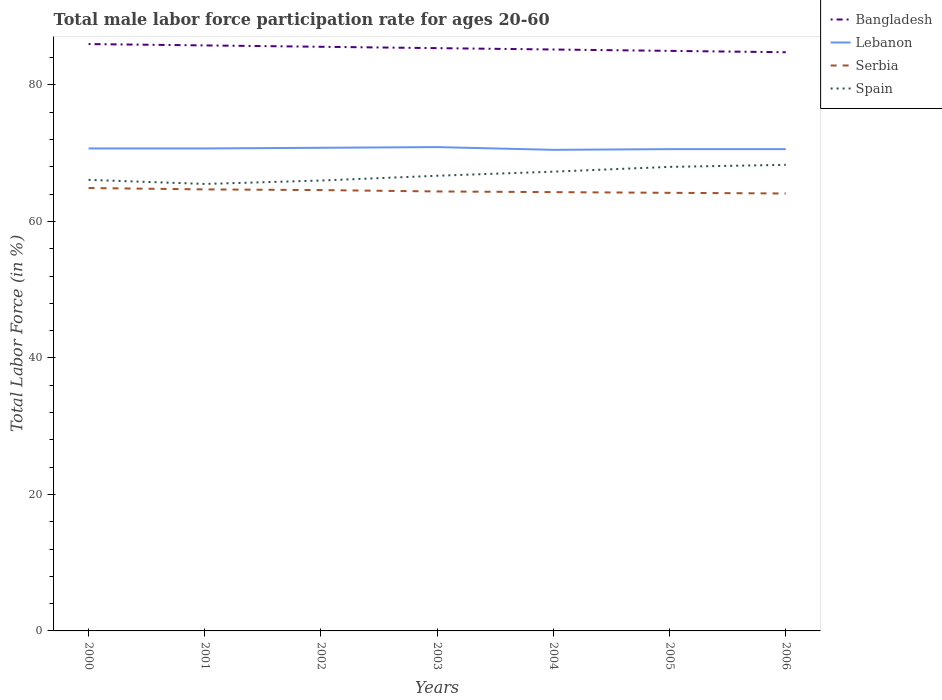Across all years, what is the maximum male labor force participation rate in Bangladesh?
Offer a very short reply. 84.8. In which year was the male labor force participation rate in Lebanon maximum?
Offer a very short reply. 2004. What is the total male labor force participation rate in Spain in the graph?
Make the answer very short. -1. What is the difference between the highest and the second highest male labor force participation rate in Serbia?
Your answer should be very brief. 0.8. How many lines are there?
Your answer should be very brief. 4. What is the difference between two consecutive major ticks on the Y-axis?
Offer a very short reply. 20. Are the values on the major ticks of Y-axis written in scientific E-notation?
Offer a terse response. No. Does the graph contain grids?
Offer a very short reply. No. Where does the legend appear in the graph?
Your answer should be very brief. Top right. How many legend labels are there?
Ensure brevity in your answer.  4. What is the title of the graph?
Your answer should be compact. Total male labor force participation rate for ages 20-60. What is the Total Labor Force (in %) of Bangladesh in 2000?
Give a very brief answer. 86. What is the Total Labor Force (in %) of Lebanon in 2000?
Provide a succinct answer. 70.7. What is the Total Labor Force (in %) in Serbia in 2000?
Your response must be concise. 64.9. What is the Total Labor Force (in %) in Spain in 2000?
Make the answer very short. 66.1. What is the Total Labor Force (in %) of Bangladesh in 2001?
Provide a succinct answer. 85.8. What is the Total Labor Force (in %) in Lebanon in 2001?
Your response must be concise. 70.7. What is the Total Labor Force (in %) of Serbia in 2001?
Your answer should be compact. 64.7. What is the Total Labor Force (in %) in Spain in 2001?
Provide a succinct answer. 65.5. What is the Total Labor Force (in %) of Bangladesh in 2002?
Provide a succinct answer. 85.6. What is the Total Labor Force (in %) of Lebanon in 2002?
Your answer should be very brief. 70.8. What is the Total Labor Force (in %) in Serbia in 2002?
Provide a succinct answer. 64.6. What is the Total Labor Force (in %) of Bangladesh in 2003?
Keep it short and to the point. 85.4. What is the Total Labor Force (in %) of Lebanon in 2003?
Give a very brief answer. 70.9. What is the Total Labor Force (in %) in Serbia in 2003?
Ensure brevity in your answer.  64.4. What is the Total Labor Force (in %) in Spain in 2003?
Provide a succinct answer. 66.7. What is the Total Labor Force (in %) of Bangladesh in 2004?
Make the answer very short. 85.2. What is the Total Labor Force (in %) in Lebanon in 2004?
Offer a terse response. 70.5. What is the Total Labor Force (in %) in Serbia in 2004?
Provide a succinct answer. 64.3. What is the Total Labor Force (in %) in Spain in 2004?
Make the answer very short. 67.3. What is the Total Labor Force (in %) of Bangladesh in 2005?
Provide a short and direct response. 85. What is the Total Labor Force (in %) in Lebanon in 2005?
Offer a very short reply. 70.6. What is the Total Labor Force (in %) in Serbia in 2005?
Make the answer very short. 64.2. What is the Total Labor Force (in %) in Spain in 2005?
Your answer should be compact. 68. What is the Total Labor Force (in %) in Bangladesh in 2006?
Provide a short and direct response. 84.8. What is the Total Labor Force (in %) in Lebanon in 2006?
Your response must be concise. 70.6. What is the Total Labor Force (in %) in Serbia in 2006?
Give a very brief answer. 64.1. What is the Total Labor Force (in %) of Spain in 2006?
Keep it short and to the point. 68.3. Across all years, what is the maximum Total Labor Force (in %) in Bangladesh?
Provide a succinct answer. 86. Across all years, what is the maximum Total Labor Force (in %) of Lebanon?
Provide a short and direct response. 70.9. Across all years, what is the maximum Total Labor Force (in %) of Serbia?
Offer a very short reply. 64.9. Across all years, what is the maximum Total Labor Force (in %) in Spain?
Keep it short and to the point. 68.3. Across all years, what is the minimum Total Labor Force (in %) in Bangladesh?
Offer a terse response. 84.8. Across all years, what is the minimum Total Labor Force (in %) in Lebanon?
Your response must be concise. 70.5. Across all years, what is the minimum Total Labor Force (in %) of Serbia?
Keep it short and to the point. 64.1. Across all years, what is the minimum Total Labor Force (in %) of Spain?
Offer a very short reply. 65.5. What is the total Total Labor Force (in %) of Bangladesh in the graph?
Offer a terse response. 597.8. What is the total Total Labor Force (in %) of Lebanon in the graph?
Your response must be concise. 494.8. What is the total Total Labor Force (in %) in Serbia in the graph?
Your response must be concise. 451.2. What is the total Total Labor Force (in %) of Spain in the graph?
Your response must be concise. 467.9. What is the difference between the Total Labor Force (in %) of Lebanon in 2000 and that in 2001?
Your answer should be compact. 0. What is the difference between the Total Labor Force (in %) of Serbia in 2000 and that in 2001?
Give a very brief answer. 0.2. What is the difference between the Total Labor Force (in %) of Bangladesh in 2000 and that in 2002?
Ensure brevity in your answer.  0.4. What is the difference between the Total Labor Force (in %) of Spain in 2000 and that in 2002?
Your answer should be compact. 0.1. What is the difference between the Total Labor Force (in %) of Serbia in 2000 and that in 2003?
Your answer should be compact. 0.5. What is the difference between the Total Labor Force (in %) of Spain in 2000 and that in 2003?
Offer a very short reply. -0.6. What is the difference between the Total Labor Force (in %) in Spain in 2000 and that in 2004?
Provide a short and direct response. -1.2. What is the difference between the Total Labor Force (in %) of Bangladesh in 2000 and that in 2005?
Ensure brevity in your answer.  1. What is the difference between the Total Labor Force (in %) of Serbia in 2000 and that in 2005?
Ensure brevity in your answer.  0.7. What is the difference between the Total Labor Force (in %) in Bangladesh in 2000 and that in 2006?
Offer a very short reply. 1.2. What is the difference between the Total Labor Force (in %) of Spain in 2000 and that in 2006?
Keep it short and to the point. -2.2. What is the difference between the Total Labor Force (in %) of Lebanon in 2001 and that in 2002?
Offer a very short reply. -0.1. What is the difference between the Total Labor Force (in %) in Serbia in 2001 and that in 2002?
Your answer should be very brief. 0.1. What is the difference between the Total Labor Force (in %) in Serbia in 2001 and that in 2003?
Provide a short and direct response. 0.3. What is the difference between the Total Labor Force (in %) of Bangladesh in 2001 and that in 2004?
Make the answer very short. 0.6. What is the difference between the Total Labor Force (in %) in Serbia in 2001 and that in 2004?
Your answer should be very brief. 0.4. What is the difference between the Total Labor Force (in %) of Spain in 2001 and that in 2004?
Keep it short and to the point. -1.8. What is the difference between the Total Labor Force (in %) of Bangladesh in 2001 and that in 2005?
Give a very brief answer. 0.8. What is the difference between the Total Labor Force (in %) of Lebanon in 2001 and that in 2005?
Ensure brevity in your answer.  0.1. What is the difference between the Total Labor Force (in %) of Bangladesh in 2001 and that in 2006?
Give a very brief answer. 1. What is the difference between the Total Labor Force (in %) of Lebanon in 2002 and that in 2003?
Your answer should be compact. -0.1. What is the difference between the Total Labor Force (in %) in Spain in 2002 and that in 2003?
Your response must be concise. -0.7. What is the difference between the Total Labor Force (in %) of Bangladesh in 2002 and that in 2004?
Offer a very short reply. 0.4. What is the difference between the Total Labor Force (in %) of Lebanon in 2002 and that in 2004?
Ensure brevity in your answer.  0.3. What is the difference between the Total Labor Force (in %) of Serbia in 2002 and that in 2004?
Provide a succinct answer. 0.3. What is the difference between the Total Labor Force (in %) in Bangladesh in 2002 and that in 2005?
Ensure brevity in your answer.  0.6. What is the difference between the Total Labor Force (in %) of Serbia in 2002 and that in 2005?
Provide a succinct answer. 0.4. What is the difference between the Total Labor Force (in %) of Spain in 2002 and that in 2006?
Offer a terse response. -2.3. What is the difference between the Total Labor Force (in %) in Bangladesh in 2003 and that in 2004?
Provide a short and direct response. 0.2. What is the difference between the Total Labor Force (in %) of Lebanon in 2003 and that in 2004?
Your answer should be very brief. 0.4. What is the difference between the Total Labor Force (in %) in Lebanon in 2003 and that in 2005?
Provide a short and direct response. 0.3. What is the difference between the Total Labor Force (in %) in Serbia in 2003 and that in 2005?
Give a very brief answer. 0.2. What is the difference between the Total Labor Force (in %) of Spain in 2003 and that in 2005?
Make the answer very short. -1.3. What is the difference between the Total Labor Force (in %) in Bangladesh in 2003 and that in 2006?
Ensure brevity in your answer.  0.6. What is the difference between the Total Labor Force (in %) of Lebanon in 2003 and that in 2006?
Offer a very short reply. 0.3. What is the difference between the Total Labor Force (in %) of Lebanon in 2004 and that in 2005?
Your answer should be compact. -0.1. What is the difference between the Total Labor Force (in %) in Serbia in 2004 and that in 2006?
Provide a short and direct response. 0.2. What is the difference between the Total Labor Force (in %) in Spain in 2004 and that in 2006?
Provide a short and direct response. -1. What is the difference between the Total Labor Force (in %) in Lebanon in 2005 and that in 2006?
Give a very brief answer. 0. What is the difference between the Total Labor Force (in %) in Spain in 2005 and that in 2006?
Provide a succinct answer. -0.3. What is the difference between the Total Labor Force (in %) of Bangladesh in 2000 and the Total Labor Force (in %) of Serbia in 2001?
Provide a short and direct response. 21.3. What is the difference between the Total Labor Force (in %) of Bangladesh in 2000 and the Total Labor Force (in %) of Spain in 2001?
Your response must be concise. 20.5. What is the difference between the Total Labor Force (in %) of Bangladesh in 2000 and the Total Labor Force (in %) of Serbia in 2002?
Provide a succinct answer. 21.4. What is the difference between the Total Labor Force (in %) of Lebanon in 2000 and the Total Labor Force (in %) of Spain in 2002?
Give a very brief answer. 4.7. What is the difference between the Total Labor Force (in %) in Serbia in 2000 and the Total Labor Force (in %) in Spain in 2002?
Make the answer very short. -1.1. What is the difference between the Total Labor Force (in %) in Bangladesh in 2000 and the Total Labor Force (in %) in Serbia in 2003?
Make the answer very short. 21.6. What is the difference between the Total Labor Force (in %) of Bangladesh in 2000 and the Total Labor Force (in %) of Spain in 2003?
Ensure brevity in your answer.  19.3. What is the difference between the Total Labor Force (in %) of Lebanon in 2000 and the Total Labor Force (in %) of Serbia in 2003?
Your answer should be compact. 6.3. What is the difference between the Total Labor Force (in %) in Lebanon in 2000 and the Total Labor Force (in %) in Spain in 2003?
Your response must be concise. 4. What is the difference between the Total Labor Force (in %) in Bangladesh in 2000 and the Total Labor Force (in %) in Serbia in 2004?
Give a very brief answer. 21.7. What is the difference between the Total Labor Force (in %) in Bangladesh in 2000 and the Total Labor Force (in %) in Spain in 2004?
Ensure brevity in your answer.  18.7. What is the difference between the Total Labor Force (in %) in Serbia in 2000 and the Total Labor Force (in %) in Spain in 2004?
Your answer should be compact. -2.4. What is the difference between the Total Labor Force (in %) of Bangladesh in 2000 and the Total Labor Force (in %) of Serbia in 2005?
Your response must be concise. 21.8. What is the difference between the Total Labor Force (in %) in Bangladesh in 2000 and the Total Labor Force (in %) in Spain in 2005?
Make the answer very short. 18. What is the difference between the Total Labor Force (in %) in Lebanon in 2000 and the Total Labor Force (in %) in Serbia in 2005?
Give a very brief answer. 6.5. What is the difference between the Total Labor Force (in %) of Lebanon in 2000 and the Total Labor Force (in %) of Spain in 2005?
Give a very brief answer. 2.7. What is the difference between the Total Labor Force (in %) in Serbia in 2000 and the Total Labor Force (in %) in Spain in 2005?
Your answer should be compact. -3.1. What is the difference between the Total Labor Force (in %) of Bangladesh in 2000 and the Total Labor Force (in %) of Serbia in 2006?
Keep it short and to the point. 21.9. What is the difference between the Total Labor Force (in %) of Lebanon in 2000 and the Total Labor Force (in %) of Serbia in 2006?
Give a very brief answer. 6.6. What is the difference between the Total Labor Force (in %) of Lebanon in 2000 and the Total Labor Force (in %) of Spain in 2006?
Offer a terse response. 2.4. What is the difference between the Total Labor Force (in %) in Serbia in 2000 and the Total Labor Force (in %) in Spain in 2006?
Provide a succinct answer. -3.4. What is the difference between the Total Labor Force (in %) in Bangladesh in 2001 and the Total Labor Force (in %) in Serbia in 2002?
Make the answer very short. 21.2. What is the difference between the Total Labor Force (in %) in Bangladesh in 2001 and the Total Labor Force (in %) in Spain in 2002?
Keep it short and to the point. 19.8. What is the difference between the Total Labor Force (in %) in Lebanon in 2001 and the Total Labor Force (in %) in Spain in 2002?
Ensure brevity in your answer.  4.7. What is the difference between the Total Labor Force (in %) in Bangladesh in 2001 and the Total Labor Force (in %) in Serbia in 2003?
Your answer should be compact. 21.4. What is the difference between the Total Labor Force (in %) in Lebanon in 2001 and the Total Labor Force (in %) in Serbia in 2003?
Provide a succinct answer. 6.3. What is the difference between the Total Labor Force (in %) of Lebanon in 2001 and the Total Labor Force (in %) of Spain in 2003?
Give a very brief answer. 4. What is the difference between the Total Labor Force (in %) in Serbia in 2001 and the Total Labor Force (in %) in Spain in 2003?
Provide a short and direct response. -2. What is the difference between the Total Labor Force (in %) in Serbia in 2001 and the Total Labor Force (in %) in Spain in 2004?
Your answer should be very brief. -2.6. What is the difference between the Total Labor Force (in %) in Bangladesh in 2001 and the Total Labor Force (in %) in Serbia in 2005?
Offer a terse response. 21.6. What is the difference between the Total Labor Force (in %) of Bangladesh in 2001 and the Total Labor Force (in %) of Spain in 2005?
Offer a terse response. 17.8. What is the difference between the Total Labor Force (in %) in Lebanon in 2001 and the Total Labor Force (in %) in Serbia in 2005?
Your answer should be very brief. 6.5. What is the difference between the Total Labor Force (in %) of Serbia in 2001 and the Total Labor Force (in %) of Spain in 2005?
Keep it short and to the point. -3.3. What is the difference between the Total Labor Force (in %) in Bangladesh in 2001 and the Total Labor Force (in %) in Lebanon in 2006?
Your answer should be very brief. 15.2. What is the difference between the Total Labor Force (in %) in Bangladesh in 2001 and the Total Labor Force (in %) in Serbia in 2006?
Your response must be concise. 21.7. What is the difference between the Total Labor Force (in %) in Lebanon in 2001 and the Total Labor Force (in %) in Spain in 2006?
Make the answer very short. 2.4. What is the difference between the Total Labor Force (in %) of Bangladesh in 2002 and the Total Labor Force (in %) of Lebanon in 2003?
Offer a terse response. 14.7. What is the difference between the Total Labor Force (in %) in Bangladesh in 2002 and the Total Labor Force (in %) in Serbia in 2003?
Make the answer very short. 21.2. What is the difference between the Total Labor Force (in %) of Serbia in 2002 and the Total Labor Force (in %) of Spain in 2003?
Provide a succinct answer. -2.1. What is the difference between the Total Labor Force (in %) in Bangladesh in 2002 and the Total Labor Force (in %) in Lebanon in 2004?
Provide a succinct answer. 15.1. What is the difference between the Total Labor Force (in %) of Bangladesh in 2002 and the Total Labor Force (in %) of Serbia in 2004?
Offer a terse response. 21.3. What is the difference between the Total Labor Force (in %) in Lebanon in 2002 and the Total Labor Force (in %) in Serbia in 2004?
Offer a very short reply. 6.5. What is the difference between the Total Labor Force (in %) of Bangladesh in 2002 and the Total Labor Force (in %) of Serbia in 2005?
Provide a succinct answer. 21.4. What is the difference between the Total Labor Force (in %) in Serbia in 2002 and the Total Labor Force (in %) in Spain in 2005?
Your response must be concise. -3.4. What is the difference between the Total Labor Force (in %) in Bangladesh in 2002 and the Total Labor Force (in %) in Lebanon in 2006?
Provide a succinct answer. 15. What is the difference between the Total Labor Force (in %) of Bangladesh in 2002 and the Total Labor Force (in %) of Serbia in 2006?
Your answer should be compact. 21.5. What is the difference between the Total Labor Force (in %) in Serbia in 2002 and the Total Labor Force (in %) in Spain in 2006?
Offer a terse response. -3.7. What is the difference between the Total Labor Force (in %) of Bangladesh in 2003 and the Total Labor Force (in %) of Serbia in 2004?
Offer a terse response. 21.1. What is the difference between the Total Labor Force (in %) in Bangladesh in 2003 and the Total Labor Force (in %) in Serbia in 2005?
Make the answer very short. 21.2. What is the difference between the Total Labor Force (in %) in Lebanon in 2003 and the Total Labor Force (in %) in Serbia in 2005?
Your answer should be very brief. 6.7. What is the difference between the Total Labor Force (in %) in Serbia in 2003 and the Total Labor Force (in %) in Spain in 2005?
Keep it short and to the point. -3.6. What is the difference between the Total Labor Force (in %) in Bangladesh in 2003 and the Total Labor Force (in %) in Serbia in 2006?
Make the answer very short. 21.3. What is the difference between the Total Labor Force (in %) of Serbia in 2003 and the Total Labor Force (in %) of Spain in 2006?
Keep it short and to the point. -3.9. What is the difference between the Total Labor Force (in %) of Bangladesh in 2004 and the Total Labor Force (in %) of Lebanon in 2005?
Your answer should be very brief. 14.6. What is the difference between the Total Labor Force (in %) of Bangladesh in 2004 and the Total Labor Force (in %) of Serbia in 2005?
Give a very brief answer. 21. What is the difference between the Total Labor Force (in %) in Lebanon in 2004 and the Total Labor Force (in %) in Spain in 2005?
Provide a short and direct response. 2.5. What is the difference between the Total Labor Force (in %) in Bangladesh in 2004 and the Total Labor Force (in %) in Serbia in 2006?
Give a very brief answer. 21.1. What is the difference between the Total Labor Force (in %) in Bangladesh in 2004 and the Total Labor Force (in %) in Spain in 2006?
Offer a very short reply. 16.9. What is the difference between the Total Labor Force (in %) of Lebanon in 2004 and the Total Labor Force (in %) of Serbia in 2006?
Provide a short and direct response. 6.4. What is the difference between the Total Labor Force (in %) in Lebanon in 2004 and the Total Labor Force (in %) in Spain in 2006?
Give a very brief answer. 2.2. What is the difference between the Total Labor Force (in %) in Serbia in 2004 and the Total Labor Force (in %) in Spain in 2006?
Your answer should be very brief. -4. What is the difference between the Total Labor Force (in %) in Bangladesh in 2005 and the Total Labor Force (in %) in Lebanon in 2006?
Your response must be concise. 14.4. What is the difference between the Total Labor Force (in %) in Bangladesh in 2005 and the Total Labor Force (in %) in Serbia in 2006?
Provide a succinct answer. 20.9. What is the average Total Labor Force (in %) in Bangladesh per year?
Make the answer very short. 85.4. What is the average Total Labor Force (in %) of Lebanon per year?
Offer a terse response. 70.69. What is the average Total Labor Force (in %) in Serbia per year?
Offer a very short reply. 64.46. What is the average Total Labor Force (in %) of Spain per year?
Your answer should be compact. 66.84. In the year 2000, what is the difference between the Total Labor Force (in %) of Bangladesh and Total Labor Force (in %) of Serbia?
Your answer should be compact. 21.1. In the year 2000, what is the difference between the Total Labor Force (in %) in Lebanon and Total Labor Force (in %) in Spain?
Provide a short and direct response. 4.6. In the year 2001, what is the difference between the Total Labor Force (in %) in Bangladesh and Total Labor Force (in %) in Lebanon?
Provide a short and direct response. 15.1. In the year 2001, what is the difference between the Total Labor Force (in %) of Bangladesh and Total Labor Force (in %) of Serbia?
Provide a short and direct response. 21.1. In the year 2001, what is the difference between the Total Labor Force (in %) in Bangladesh and Total Labor Force (in %) in Spain?
Provide a succinct answer. 20.3. In the year 2001, what is the difference between the Total Labor Force (in %) in Lebanon and Total Labor Force (in %) in Spain?
Give a very brief answer. 5.2. In the year 2002, what is the difference between the Total Labor Force (in %) of Bangladesh and Total Labor Force (in %) of Lebanon?
Ensure brevity in your answer.  14.8. In the year 2002, what is the difference between the Total Labor Force (in %) of Bangladesh and Total Labor Force (in %) of Serbia?
Provide a short and direct response. 21. In the year 2002, what is the difference between the Total Labor Force (in %) of Bangladesh and Total Labor Force (in %) of Spain?
Keep it short and to the point. 19.6. In the year 2002, what is the difference between the Total Labor Force (in %) in Lebanon and Total Labor Force (in %) in Spain?
Your response must be concise. 4.8. In the year 2003, what is the difference between the Total Labor Force (in %) of Bangladesh and Total Labor Force (in %) of Spain?
Your response must be concise. 18.7. In the year 2003, what is the difference between the Total Labor Force (in %) of Lebanon and Total Labor Force (in %) of Serbia?
Ensure brevity in your answer.  6.5. In the year 2003, what is the difference between the Total Labor Force (in %) of Lebanon and Total Labor Force (in %) of Spain?
Offer a terse response. 4.2. In the year 2003, what is the difference between the Total Labor Force (in %) of Serbia and Total Labor Force (in %) of Spain?
Your answer should be compact. -2.3. In the year 2004, what is the difference between the Total Labor Force (in %) of Bangladesh and Total Labor Force (in %) of Serbia?
Offer a very short reply. 20.9. In the year 2004, what is the difference between the Total Labor Force (in %) in Bangladesh and Total Labor Force (in %) in Spain?
Your answer should be very brief. 17.9. In the year 2004, what is the difference between the Total Labor Force (in %) of Lebanon and Total Labor Force (in %) of Serbia?
Your answer should be compact. 6.2. In the year 2005, what is the difference between the Total Labor Force (in %) in Bangladesh and Total Labor Force (in %) in Lebanon?
Make the answer very short. 14.4. In the year 2005, what is the difference between the Total Labor Force (in %) in Bangladesh and Total Labor Force (in %) in Serbia?
Your answer should be very brief. 20.8. In the year 2005, what is the difference between the Total Labor Force (in %) of Bangladesh and Total Labor Force (in %) of Spain?
Make the answer very short. 17. In the year 2005, what is the difference between the Total Labor Force (in %) in Serbia and Total Labor Force (in %) in Spain?
Offer a very short reply. -3.8. In the year 2006, what is the difference between the Total Labor Force (in %) of Bangladesh and Total Labor Force (in %) of Serbia?
Your answer should be very brief. 20.7. In the year 2006, what is the difference between the Total Labor Force (in %) of Lebanon and Total Labor Force (in %) of Serbia?
Your response must be concise. 6.5. In the year 2006, what is the difference between the Total Labor Force (in %) in Serbia and Total Labor Force (in %) in Spain?
Your answer should be very brief. -4.2. What is the ratio of the Total Labor Force (in %) in Lebanon in 2000 to that in 2001?
Make the answer very short. 1. What is the ratio of the Total Labor Force (in %) of Spain in 2000 to that in 2001?
Ensure brevity in your answer.  1.01. What is the ratio of the Total Labor Force (in %) in Lebanon in 2000 to that in 2002?
Offer a very short reply. 1. What is the ratio of the Total Labor Force (in %) in Serbia in 2000 to that in 2002?
Keep it short and to the point. 1. What is the ratio of the Total Labor Force (in %) of Lebanon in 2000 to that in 2003?
Offer a terse response. 1. What is the ratio of the Total Labor Force (in %) in Serbia in 2000 to that in 2003?
Keep it short and to the point. 1.01. What is the ratio of the Total Labor Force (in %) in Spain in 2000 to that in 2003?
Ensure brevity in your answer.  0.99. What is the ratio of the Total Labor Force (in %) in Bangladesh in 2000 to that in 2004?
Offer a terse response. 1.01. What is the ratio of the Total Labor Force (in %) of Serbia in 2000 to that in 2004?
Your answer should be very brief. 1.01. What is the ratio of the Total Labor Force (in %) of Spain in 2000 to that in 2004?
Make the answer very short. 0.98. What is the ratio of the Total Labor Force (in %) of Bangladesh in 2000 to that in 2005?
Provide a short and direct response. 1.01. What is the ratio of the Total Labor Force (in %) of Lebanon in 2000 to that in 2005?
Provide a short and direct response. 1. What is the ratio of the Total Labor Force (in %) in Serbia in 2000 to that in 2005?
Make the answer very short. 1.01. What is the ratio of the Total Labor Force (in %) of Spain in 2000 to that in 2005?
Ensure brevity in your answer.  0.97. What is the ratio of the Total Labor Force (in %) in Bangladesh in 2000 to that in 2006?
Provide a succinct answer. 1.01. What is the ratio of the Total Labor Force (in %) in Lebanon in 2000 to that in 2006?
Your response must be concise. 1. What is the ratio of the Total Labor Force (in %) in Serbia in 2000 to that in 2006?
Your answer should be very brief. 1.01. What is the ratio of the Total Labor Force (in %) in Spain in 2000 to that in 2006?
Your answer should be very brief. 0.97. What is the ratio of the Total Labor Force (in %) in Lebanon in 2001 to that in 2002?
Offer a very short reply. 1. What is the ratio of the Total Labor Force (in %) in Serbia in 2001 to that in 2002?
Provide a short and direct response. 1. What is the ratio of the Total Labor Force (in %) of Bangladesh in 2001 to that in 2003?
Provide a succinct answer. 1. What is the ratio of the Total Labor Force (in %) of Spain in 2001 to that in 2003?
Give a very brief answer. 0.98. What is the ratio of the Total Labor Force (in %) in Bangladesh in 2001 to that in 2004?
Provide a short and direct response. 1.01. What is the ratio of the Total Labor Force (in %) in Lebanon in 2001 to that in 2004?
Your response must be concise. 1. What is the ratio of the Total Labor Force (in %) in Spain in 2001 to that in 2004?
Provide a short and direct response. 0.97. What is the ratio of the Total Labor Force (in %) in Bangladesh in 2001 to that in 2005?
Make the answer very short. 1.01. What is the ratio of the Total Labor Force (in %) in Lebanon in 2001 to that in 2005?
Provide a succinct answer. 1. What is the ratio of the Total Labor Force (in %) in Serbia in 2001 to that in 2005?
Provide a short and direct response. 1.01. What is the ratio of the Total Labor Force (in %) in Spain in 2001 to that in 2005?
Your answer should be compact. 0.96. What is the ratio of the Total Labor Force (in %) in Bangladesh in 2001 to that in 2006?
Keep it short and to the point. 1.01. What is the ratio of the Total Labor Force (in %) in Serbia in 2001 to that in 2006?
Keep it short and to the point. 1.01. What is the ratio of the Total Labor Force (in %) in Bangladesh in 2002 to that in 2003?
Ensure brevity in your answer.  1. What is the ratio of the Total Labor Force (in %) in Lebanon in 2002 to that in 2003?
Provide a short and direct response. 1. What is the ratio of the Total Labor Force (in %) in Spain in 2002 to that in 2003?
Your answer should be compact. 0.99. What is the ratio of the Total Labor Force (in %) of Bangladesh in 2002 to that in 2004?
Make the answer very short. 1. What is the ratio of the Total Labor Force (in %) of Lebanon in 2002 to that in 2004?
Your response must be concise. 1. What is the ratio of the Total Labor Force (in %) in Serbia in 2002 to that in 2004?
Keep it short and to the point. 1. What is the ratio of the Total Labor Force (in %) in Spain in 2002 to that in 2004?
Your response must be concise. 0.98. What is the ratio of the Total Labor Force (in %) in Bangladesh in 2002 to that in 2005?
Keep it short and to the point. 1.01. What is the ratio of the Total Labor Force (in %) in Lebanon in 2002 to that in 2005?
Provide a succinct answer. 1. What is the ratio of the Total Labor Force (in %) of Serbia in 2002 to that in 2005?
Keep it short and to the point. 1.01. What is the ratio of the Total Labor Force (in %) of Spain in 2002 to that in 2005?
Offer a very short reply. 0.97. What is the ratio of the Total Labor Force (in %) of Bangladesh in 2002 to that in 2006?
Provide a short and direct response. 1.01. What is the ratio of the Total Labor Force (in %) of Lebanon in 2002 to that in 2006?
Provide a short and direct response. 1. What is the ratio of the Total Labor Force (in %) of Spain in 2002 to that in 2006?
Your answer should be compact. 0.97. What is the ratio of the Total Labor Force (in %) in Serbia in 2003 to that in 2004?
Offer a very short reply. 1. What is the ratio of the Total Labor Force (in %) of Spain in 2003 to that in 2004?
Your answer should be very brief. 0.99. What is the ratio of the Total Labor Force (in %) of Bangladesh in 2003 to that in 2005?
Offer a very short reply. 1. What is the ratio of the Total Labor Force (in %) in Lebanon in 2003 to that in 2005?
Offer a terse response. 1. What is the ratio of the Total Labor Force (in %) of Spain in 2003 to that in 2005?
Give a very brief answer. 0.98. What is the ratio of the Total Labor Force (in %) of Bangladesh in 2003 to that in 2006?
Ensure brevity in your answer.  1.01. What is the ratio of the Total Labor Force (in %) of Spain in 2003 to that in 2006?
Provide a short and direct response. 0.98. What is the ratio of the Total Labor Force (in %) in Lebanon in 2004 to that in 2005?
Offer a very short reply. 1. What is the ratio of the Total Labor Force (in %) of Spain in 2004 to that in 2005?
Keep it short and to the point. 0.99. What is the ratio of the Total Labor Force (in %) in Spain in 2004 to that in 2006?
Make the answer very short. 0.99. What is the ratio of the Total Labor Force (in %) of Lebanon in 2005 to that in 2006?
Offer a very short reply. 1. What is the ratio of the Total Labor Force (in %) in Serbia in 2005 to that in 2006?
Your answer should be compact. 1. What is the difference between the highest and the second highest Total Labor Force (in %) in Bangladesh?
Keep it short and to the point. 0.2. What is the difference between the highest and the second highest Total Labor Force (in %) in Spain?
Keep it short and to the point. 0.3. What is the difference between the highest and the lowest Total Labor Force (in %) in Bangladesh?
Make the answer very short. 1.2. What is the difference between the highest and the lowest Total Labor Force (in %) in Spain?
Make the answer very short. 2.8. 